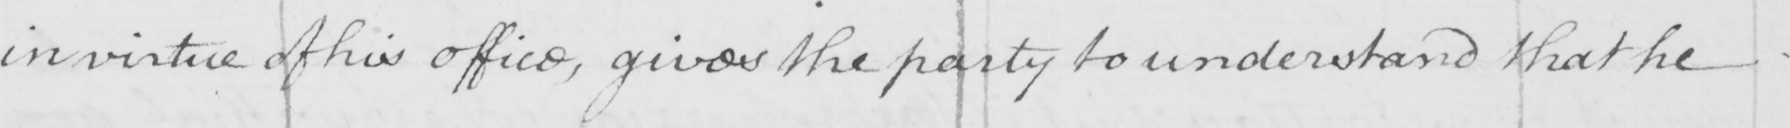Transcribe the text shown in this historical manuscript line. in virtue of his office , gives the party to understand that he 